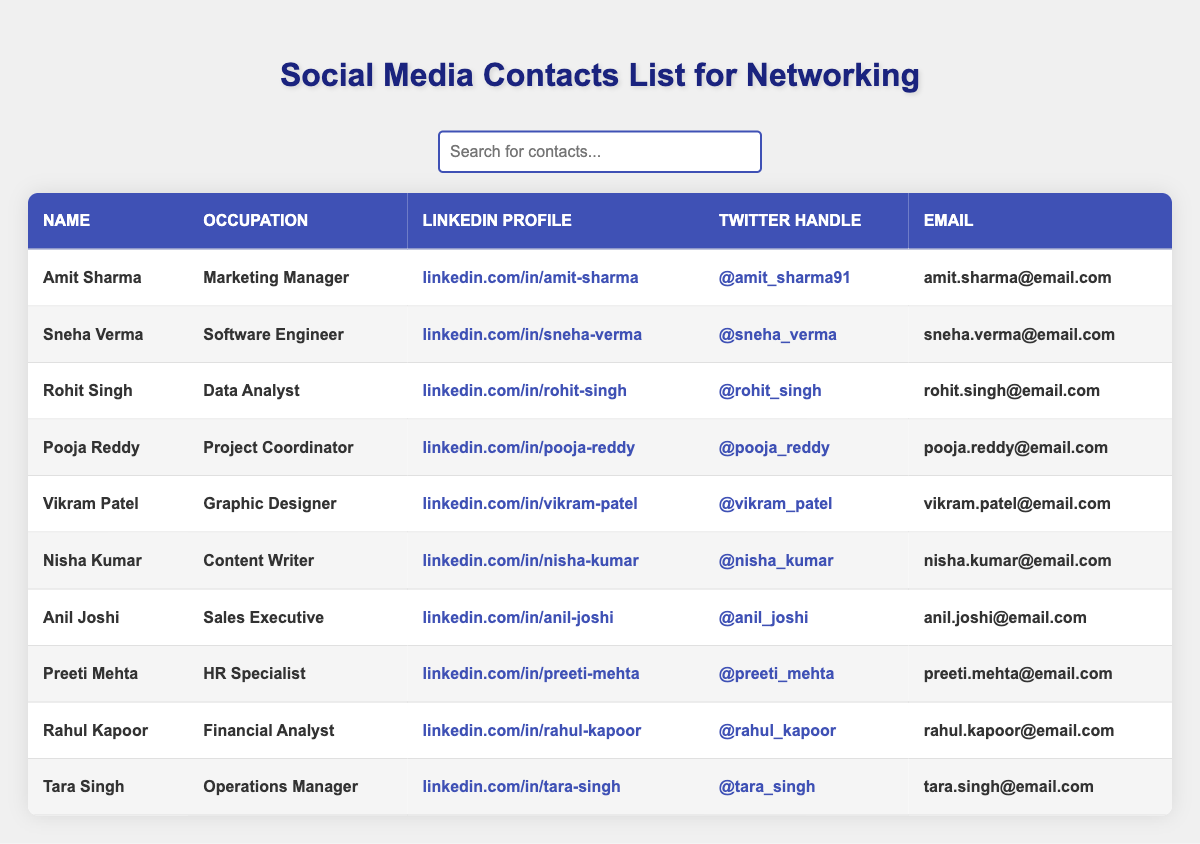What is the occupation of Amit Sharma? The table lists Amit Sharma's occupation in the second column. Looking at that column next to his name, his occupation is "Marketing Manager."
Answer: Marketing Manager What is Pooja Reddy's email address? Pooja Reddy's email address is found in the last column of the row where her name appears. The email listed is "pooja.reddy@email.com."
Answer: pooja.reddy@email.com Which two individuals work in technology-related fields? The table shows occupations for all individuals. By identifying the relevant rows, Sneha Verma (Software Engineer) and Rohit Singh (Data Analyst) are the two individuals in technology-related fields.
Answer: Sneha Verma and Rohit Singh How many contacts are listed in the table? To determine the total number of contacts, I count the number of rows under the header, excluding the header row. There are 10 contacts listed in total.
Answer: 10 Is there a contact who specializes in HR? By looking through the occupations listed in the table, I find that Preeti Mehta is the contact who specializes in HR, as indicated in her occupation.
Answer: Yes What is the LinkedIn profile of Tara Singh? Tara Singh's LinkedIn profile can be found in the third column of her row. The link provided is "linkedin.com/in/tara-singh."
Answer: linkedin.com/in/tara-singh If I wanted to connect with someone who is a Content Writer, who should I reach out to? The only individual listed under the occupation of "Content Writer" is Nisha Kumar, as seen in the occupation column next to her name.
Answer: Nisha Kumar Which of the listed occupations has the highest level of managerial responsibility? The occupations that imply management include "Operations Manager" and "Project Coordinator." Comparing both, "Operations Manager" (held by Tara Singh) typically carries more responsibility than "Project Coordinator" (held by Pooja Reddy).
Answer: Operations Manager What is the Twitter handle for Rahul Kapoor? Rahul Kapoor's Twitter handle is listed in the fourth column under his row, which shows "@rahul_kapoor."
Answer: @rahul_kapoor Who has the email address ending in "email.com" and is a Sales Executive? I find Anil Joshi in the table, whose email address listed in the last column ends with "email.com."
Answer: Anil Joshi 